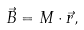<formula> <loc_0><loc_0><loc_500><loc_500>\vec { B } = M \cdot \vec { r } ,</formula> 